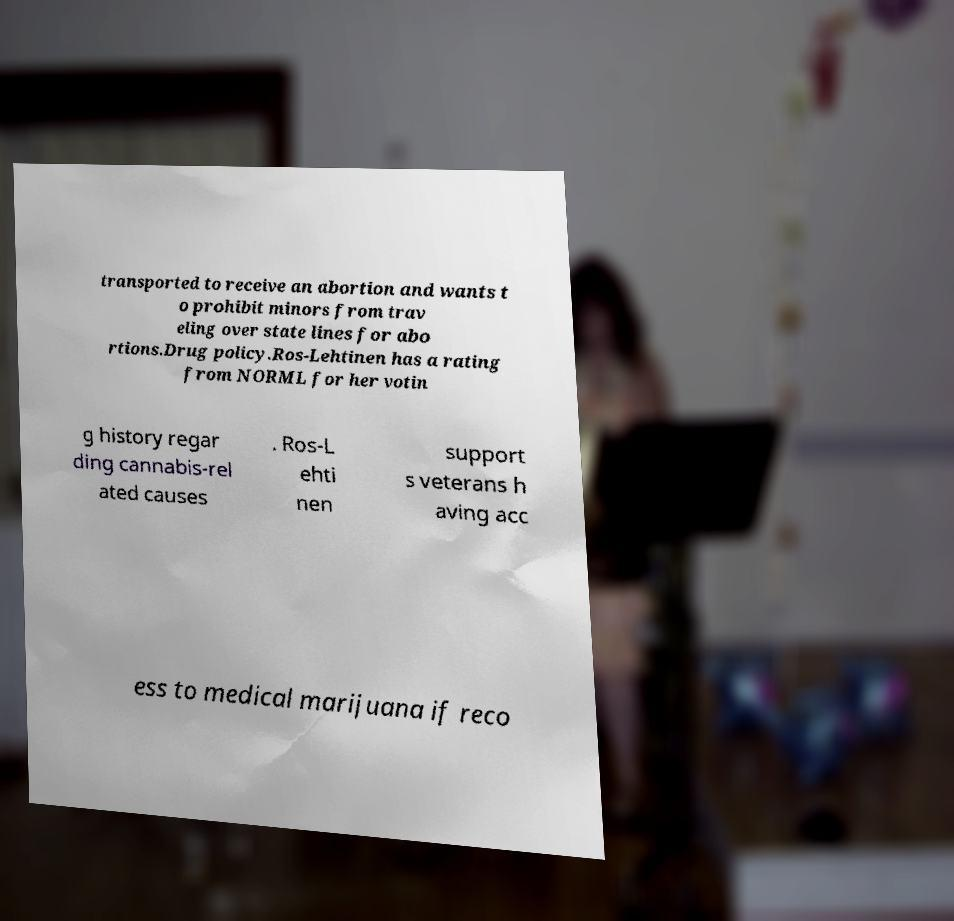What messages or text are displayed in this image? I need them in a readable, typed format. transported to receive an abortion and wants t o prohibit minors from trav eling over state lines for abo rtions.Drug policy.Ros-Lehtinen has a rating from NORML for her votin g history regar ding cannabis-rel ated causes . Ros-L ehti nen support s veterans h aving acc ess to medical marijuana if reco 